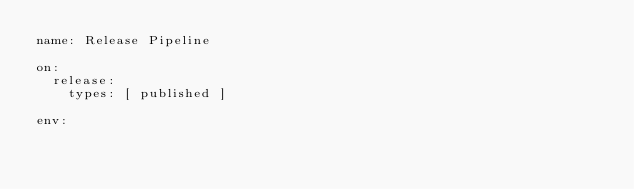Convert code to text. <code><loc_0><loc_0><loc_500><loc_500><_YAML_>name: Release Pipeline

on:
  release:
    types: [ published ]

env:</code> 